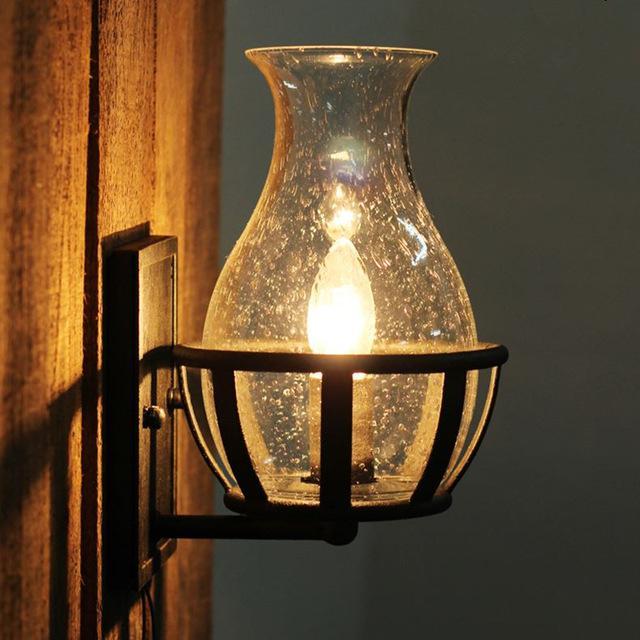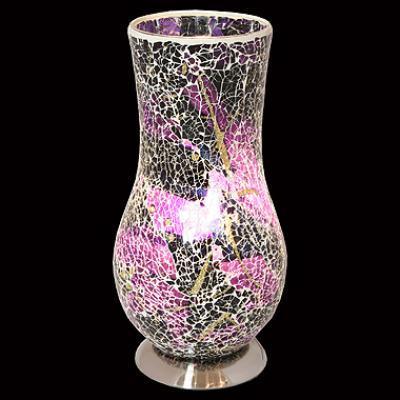The first image is the image on the left, the second image is the image on the right. Assess this claim about the two images: "The right image shows a glowing egg shape on a black base, while the left image shows a vase with a flat, open top.". Correct or not? Answer yes or no. No. The first image is the image on the left, the second image is the image on the right. Assess this claim about the two images: "there is a lamp shaped like an egg with the light reflecting on the wall and shiny surface it is sitting on, the base of the lamp is black and has a white line towards the top". Correct or not? Answer yes or no. No. 